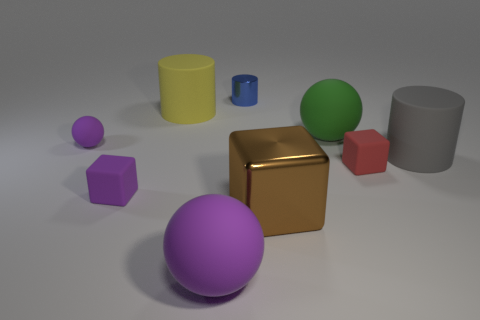Subtract all big shiny blocks. How many blocks are left? 2 Subtract all purple balls. How many balls are left? 1 Subtract all cylinders. How many objects are left? 6 Add 1 big objects. How many objects exist? 10 Subtract 0 cyan blocks. How many objects are left? 9 Subtract 2 cylinders. How many cylinders are left? 1 Subtract all green cubes. Subtract all blue balls. How many cubes are left? 3 Subtract all green blocks. How many red cylinders are left? 0 Subtract all shiny objects. Subtract all tiny blue objects. How many objects are left? 6 Add 5 big matte cylinders. How many big matte cylinders are left? 7 